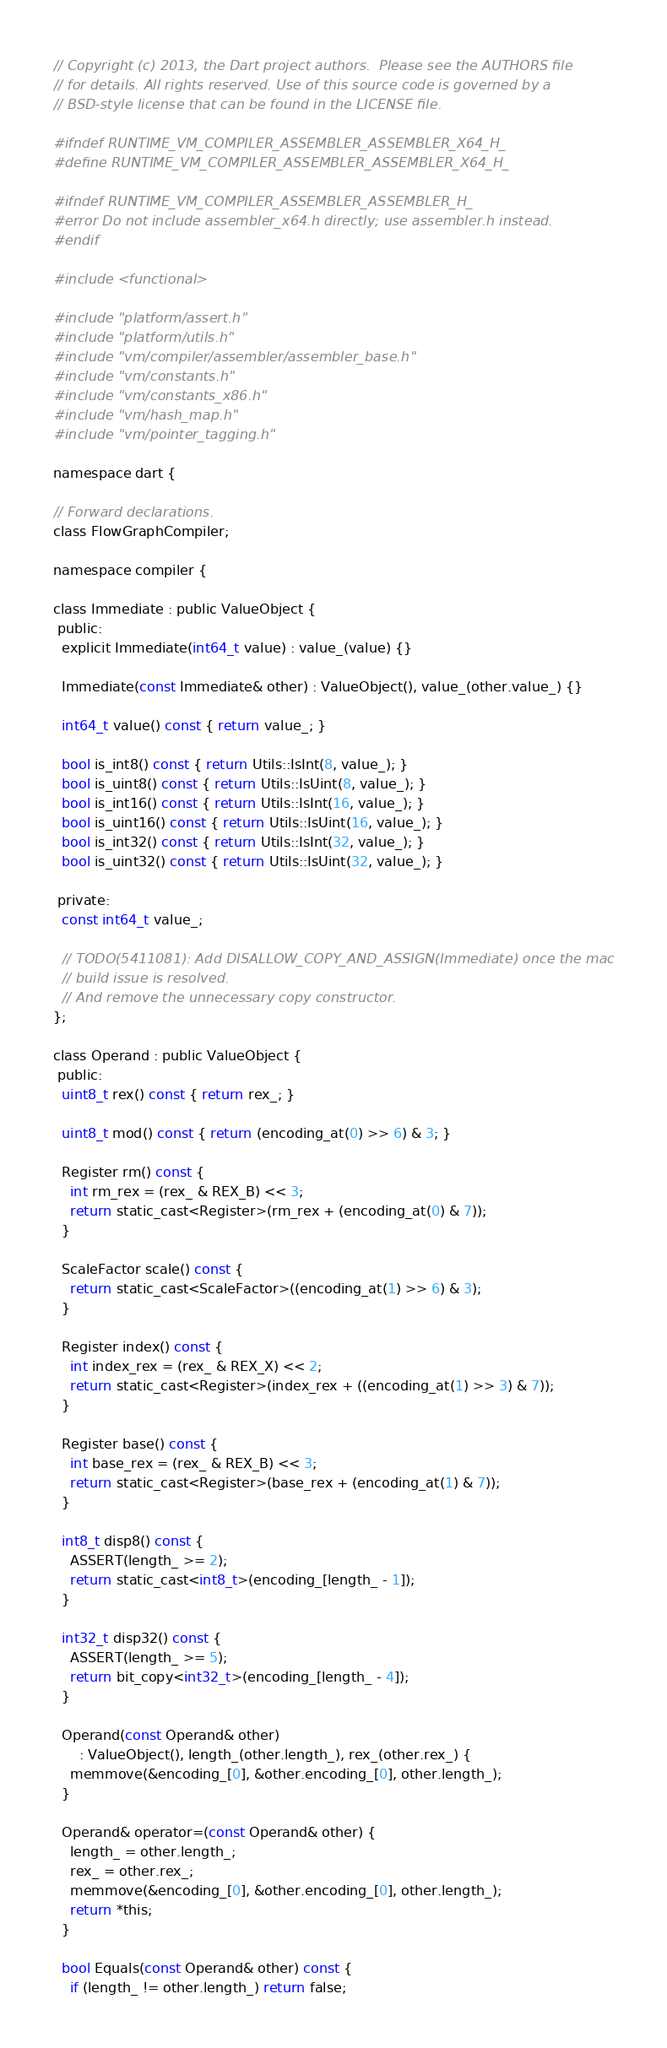Convert code to text. <code><loc_0><loc_0><loc_500><loc_500><_C_>// Copyright (c) 2013, the Dart project authors.  Please see the AUTHORS file
// for details. All rights reserved. Use of this source code is governed by a
// BSD-style license that can be found in the LICENSE file.

#ifndef RUNTIME_VM_COMPILER_ASSEMBLER_ASSEMBLER_X64_H_
#define RUNTIME_VM_COMPILER_ASSEMBLER_ASSEMBLER_X64_H_

#ifndef RUNTIME_VM_COMPILER_ASSEMBLER_ASSEMBLER_H_
#error Do not include assembler_x64.h directly; use assembler.h instead.
#endif

#include <functional>

#include "platform/assert.h"
#include "platform/utils.h"
#include "vm/compiler/assembler/assembler_base.h"
#include "vm/constants.h"
#include "vm/constants_x86.h"
#include "vm/hash_map.h"
#include "vm/pointer_tagging.h"

namespace dart {

// Forward declarations.
class FlowGraphCompiler;

namespace compiler {

class Immediate : public ValueObject {
 public:
  explicit Immediate(int64_t value) : value_(value) {}

  Immediate(const Immediate& other) : ValueObject(), value_(other.value_) {}

  int64_t value() const { return value_; }

  bool is_int8() const { return Utils::IsInt(8, value_); }
  bool is_uint8() const { return Utils::IsUint(8, value_); }
  bool is_int16() const { return Utils::IsInt(16, value_); }
  bool is_uint16() const { return Utils::IsUint(16, value_); }
  bool is_int32() const { return Utils::IsInt(32, value_); }
  bool is_uint32() const { return Utils::IsUint(32, value_); }

 private:
  const int64_t value_;

  // TODO(5411081): Add DISALLOW_COPY_AND_ASSIGN(Immediate) once the mac
  // build issue is resolved.
  // And remove the unnecessary copy constructor.
};

class Operand : public ValueObject {
 public:
  uint8_t rex() const { return rex_; }

  uint8_t mod() const { return (encoding_at(0) >> 6) & 3; }

  Register rm() const {
    int rm_rex = (rex_ & REX_B) << 3;
    return static_cast<Register>(rm_rex + (encoding_at(0) & 7));
  }

  ScaleFactor scale() const {
    return static_cast<ScaleFactor>((encoding_at(1) >> 6) & 3);
  }

  Register index() const {
    int index_rex = (rex_ & REX_X) << 2;
    return static_cast<Register>(index_rex + ((encoding_at(1) >> 3) & 7));
  }

  Register base() const {
    int base_rex = (rex_ & REX_B) << 3;
    return static_cast<Register>(base_rex + (encoding_at(1) & 7));
  }

  int8_t disp8() const {
    ASSERT(length_ >= 2);
    return static_cast<int8_t>(encoding_[length_ - 1]);
  }

  int32_t disp32() const {
    ASSERT(length_ >= 5);
    return bit_copy<int32_t>(encoding_[length_ - 4]);
  }

  Operand(const Operand& other)
      : ValueObject(), length_(other.length_), rex_(other.rex_) {
    memmove(&encoding_[0], &other.encoding_[0], other.length_);
  }

  Operand& operator=(const Operand& other) {
    length_ = other.length_;
    rex_ = other.rex_;
    memmove(&encoding_[0], &other.encoding_[0], other.length_);
    return *this;
  }

  bool Equals(const Operand& other) const {
    if (length_ != other.length_) return false;</code> 